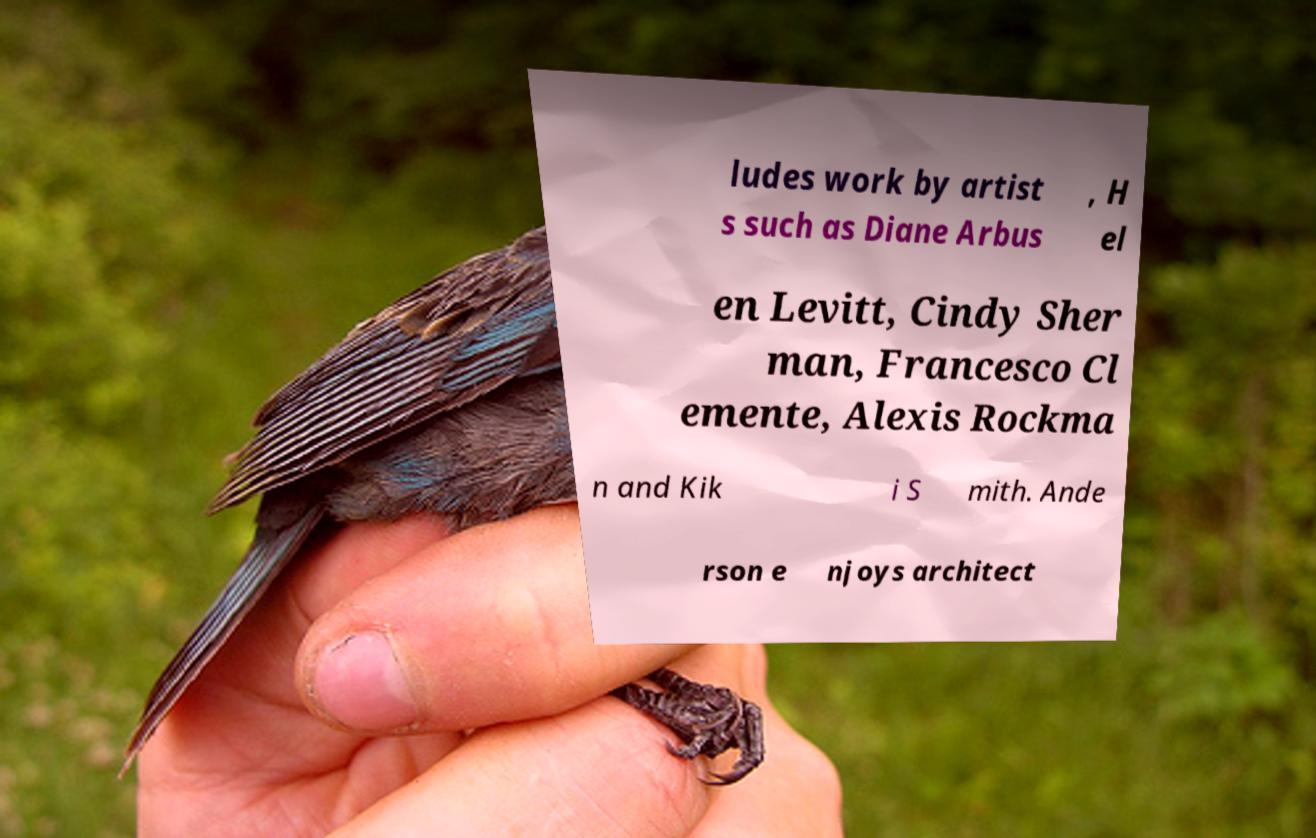Could you extract and type out the text from this image? ludes work by artist s such as Diane Arbus , H el en Levitt, Cindy Sher man, Francesco Cl emente, Alexis Rockma n and Kik i S mith. Ande rson e njoys architect 